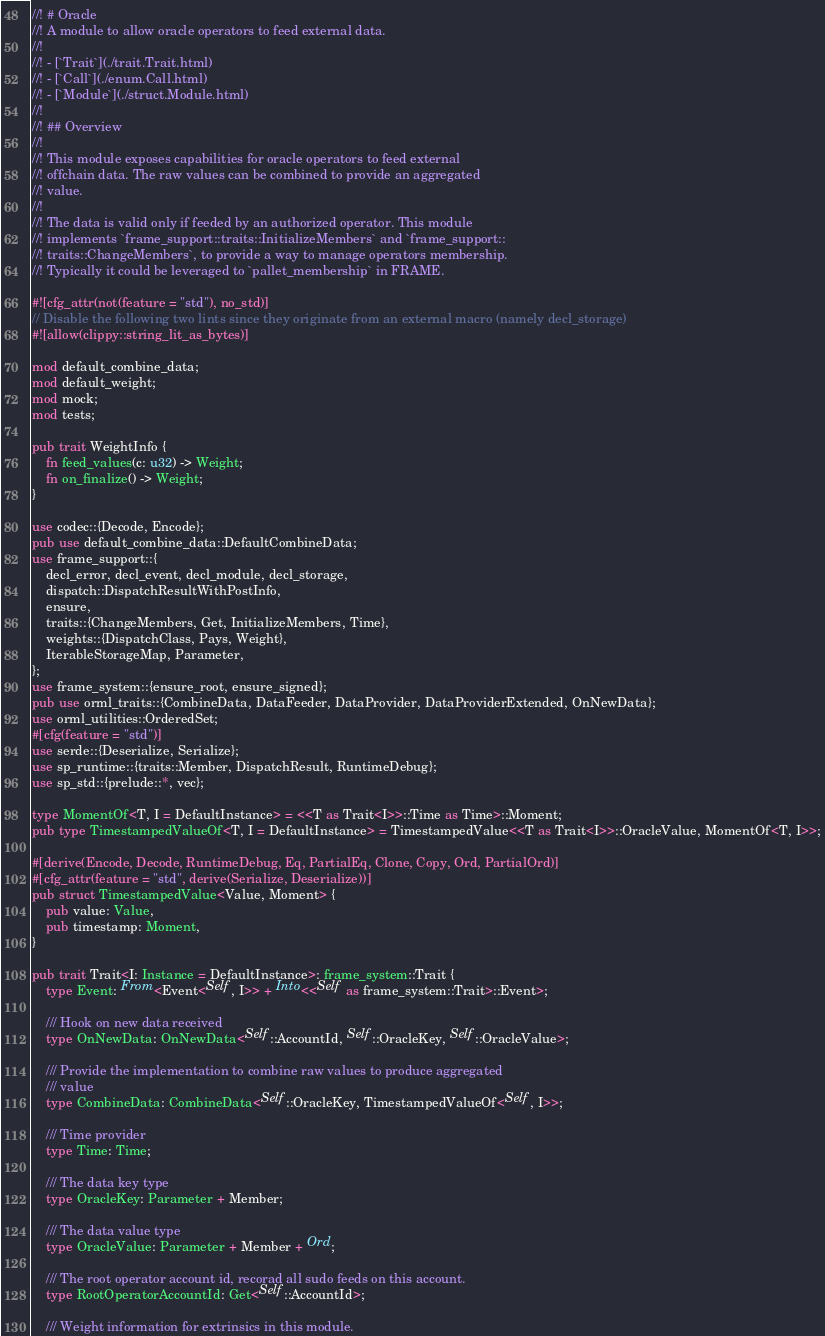Convert code to text. <code><loc_0><loc_0><loc_500><loc_500><_Rust_>//! # Oracle
//! A module to allow oracle operators to feed external data.
//!
//! - [`Trait`](./trait.Trait.html)
//! - [`Call`](./enum.Call.html)
//! - [`Module`](./struct.Module.html)
//!
//! ## Overview
//!
//! This module exposes capabilities for oracle operators to feed external
//! offchain data. The raw values can be combined to provide an aggregated
//! value.
//!
//! The data is valid only if feeded by an authorized operator. This module
//! implements `frame_support::traits::InitializeMembers` and `frame_support::
//! traits::ChangeMembers`, to provide a way to manage operators membership.
//! Typically it could be leveraged to `pallet_membership` in FRAME.

#![cfg_attr(not(feature = "std"), no_std)]
// Disable the following two lints since they originate from an external macro (namely decl_storage)
#![allow(clippy::string_lit_as_bytes)]

mod default_combine_data;
mod default_weight;
mod mock;
mod tests;

pub trait WeightInfo {
	fn feed_values(c: u32) -> Weight;
	fn on_finalize() -> Weight;
}

use codec::{Decode, Encode};
pub use default_combine_data::DefaultCombineData;
use frame_support::{
	decl_error, decl_event, decl_module, decl_storage,
	dispatch::DispatchResultWithPostInfo,
	ensure,
	traits::{ChangeMembers, Get, InitializeMembers, Time},
	weights::{DispatchClass, Pays, Weight},
	IterableStorageMap, Parameter,
};
use frame_system::{ensure_root, ensure_signed};
pub use orml_traits::{CombineData, DataFeeder, DataProvider, DataProviderExtended, OnNewData};
use orml_utilities::OrderedSet;
#[cfg(feature = "std")]
use serde::{Deserialize, Serialize};
use sp_runtime::{traits::Member, DispatchResult, RuntimeDebug};
use sp_std::{prelude::*, vec};

type MomentOf<T, I = DefaultInstance> = <<T as Trait<I>>::Time as Time>::Moment;
pub type TimestampedValueOf<T, I = DefaultInstance> = TimestampedValue<<T as Trait<I>>::OracleValue, MomentOf<T, I>>;

#[derive(Encode, Decode, RuntimeDebug, Eq, PartialEq, Clone, Copy, Ord, PartialOrd)]
#[cfg_attr(feature = "std", derive(Serialize, Deserialize))]
pub struct TimestampedValue<Value, Moment> {
	pub value: Value,
	pub timestamp: Moment,
}

pub trait Trait<I: Instance = DefaultInstance>: frame_system::Trait {
	type Event: From<Event<Self, I>> + Into<<Self as frame_system::Trait>::Event>;

	/// Hook on new data received
	type OnNewData: OnNewData<Self::AccountId, Self::OracleKey, Self::OracleValue>;

	/// Provide the implementation to combine raw values to produce aggregated
	/// value
	type CombineData: CombineData<Self::OracleKey, TimestampedValueOf<Self, I>>;

	/// Time provider
	type Time: Time;

	/// The data key type
	type OracleKey: Parameter + Member;

	/// The data value type
	type OracleValue: Parameter + Member + Ord;

	/// The root operator account id, recorad all sudo feeds on this account.
	type RootOperatorAccountId: Get<Self::AccountId>;

	/// Weight information for extrinsics in this module.</code> 